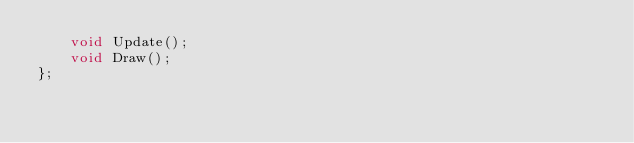Convert code to text. <code><loc_0><loc_0><loc_500><loc_500><_C_>	void Update();
	void Draw();
};

</code> 